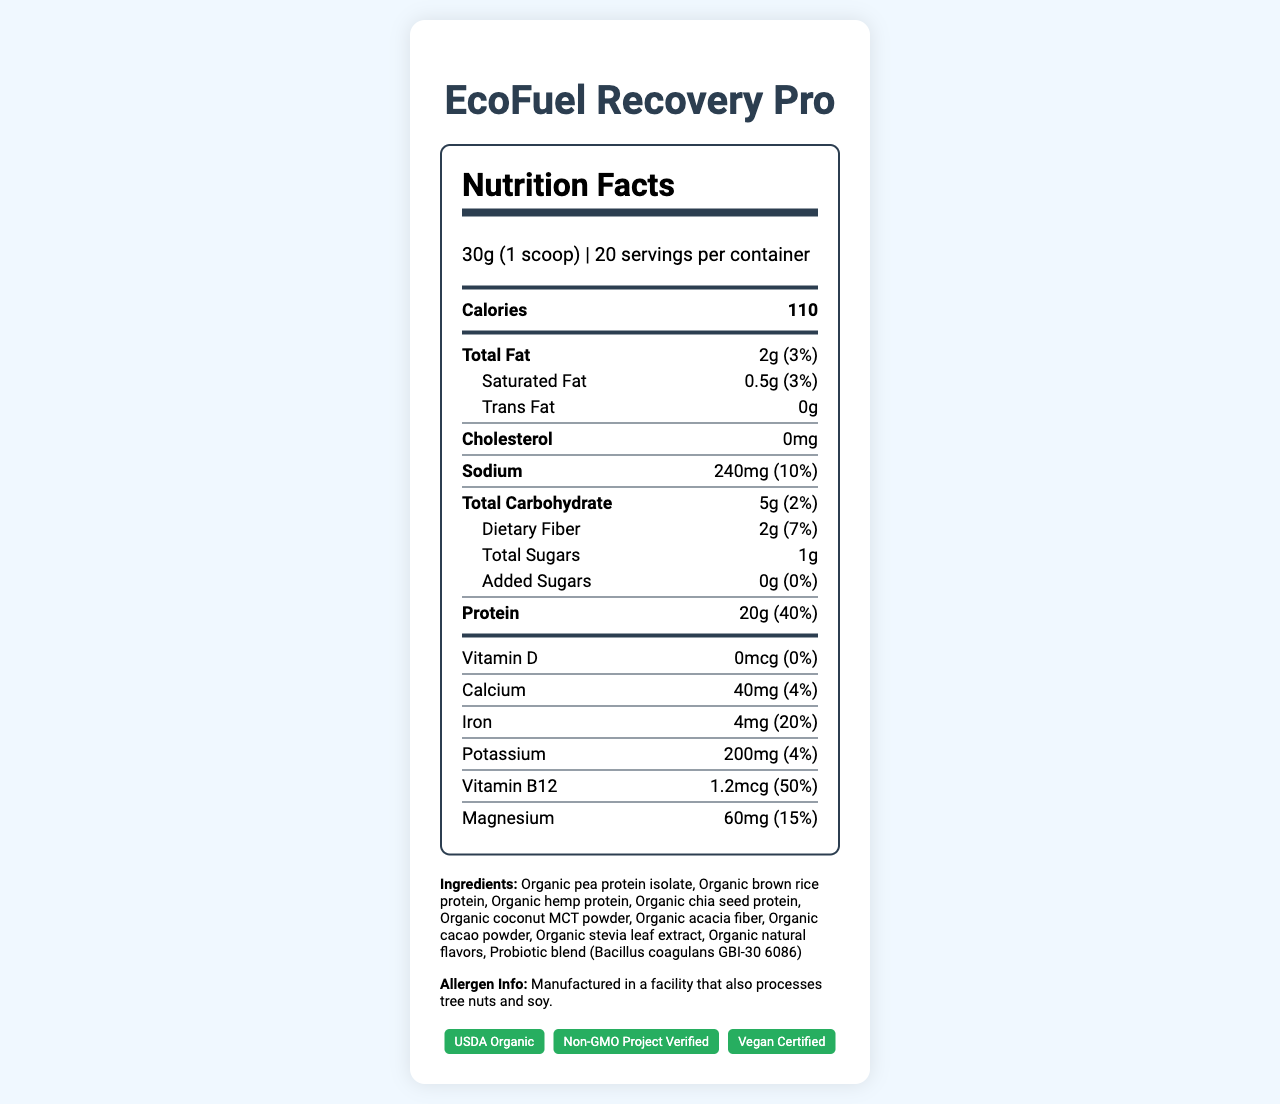who is the target market for EcoFuel Recovery Pro? The "entrepreneur_notes" section specifies the target market for the product.
Answer: Health-conscious professionals and athletes what is the serving size of EcoFuel Recovery Pro? The "serving_size" value indicates that each serving is 30 grams or 1 scoop.
Answer: 30g (1 scoop) how many servings are there per container? The "servings_per_container" field states that there are 20 servings in each container.
Answer: 20 servings per container how many calories are in one serving of EcoFuel Recovery Pro? The "calories" field specifies that one serving has 110 calories.
Answer: 110 calories which certifications does EcoFuel Recovery Pro have? A. USDA Organic B. Non-GMO Project Verified C. Vegan Certified D. All of the above The "certifications" section lists USDA Organic, Non-GMO Project Verified, and Vegan Certified.
Answer: D what is the percentage daily value of protein in one serving? The "protein" field indicates that one serving provides 40% of the daily value of protein.
Answer: 40% how much total fat is in one serving of EcoFuel Recovery Pro? The "total_fat" field shows there are 2 grams of total fat, which is 3% of the daily value.
Answer: 2g (3%) does the product contain any cholesterol? The "cholesterol" field shows 0mg, indicating the product contains no cholesterol.
Answer: No what are the unique selling points of EcoFuel Recovery Pro? The "unique_selling_points" section in the entrepreneur_notes provides these details.
Answer: Organic ingredients for clean energy, diverse protein sources for complete amino acid profile, added probiotics for digestive health, sustainable packaging how much magnesium is in one serving? The "magnesium" field shows that one serving contains 60mg of magnesium, which is 15% of the daily value.
Answer: 60mg (15%) how much added sugar is in one serving? The "added_sugars" field indicates that there is no added sugar in one serving.
Answer: 0g how much iron is in each serving? The "iron" field notes that one serving contains 4mg of iron, or 20% of the daily value.
Answer: 4mg (20% daily value) which ingredient is not in EcoFuel Recovery Pro? A. Organic pea protein isolate B. Whey protein C. Organic chia seed protein D. Organic coconut MCT powder The ingredients list shows no mention of whey protein.
Answer: B what is the primary benefit of subscription model for EcoFuel Recovery Pro described in the document? The "subscription_model" section mentions offering a 15% discount on monthly subscriptions to ensure recurring revenue.
Answer: Ensure recurring revenue with a 15% discount is EcoFuel Recovery Pro manufactured in a facility that processes tree nuts? The allergen_info indicates that the product is manufactured in a facility that also processes tree nuts and soy.
Answer: Yes what benefits do probiotics add to EcoFuel Recovery Pro? The entrepreneur_notes section states that added probiotics support digestive health.
Answer: Digestive health what is the total carbohydrate content per serving? The "total_carbohydrate" field indicates that one serving contains 5g of carbohydrates, which is 2% of the daily value.
Answer: 5g (2% daily value) describe the main idea of the document. This summary highlights the key aspects of EcoFuel Recovery Pro, including its nutritional values, unique selling points, and target market.
Answer: EcoFuel Recovery Pro is an organic, plant-based protein powder formulated to support muscle recovery and sustained energy, targeting health-conscious professionals and athletes. It features a diverse protein profile, added probiotics, and sustainability certifications. It has 110 calories per serving and provides significant protein while having low fat and no added sugars. The product also contains 20 servings per container, is allergy-aware, and offers potential cross-sell and subscription opportunities. can you calculate the total grams of protein in the entire container? With 20 servings per container and 20g of protein per serving, the total protein is 20 servings * 20g = 400g.
Answer: 400g what is the profit margin for EcoFuel Recovery Pro? The entrepreneur_notes section specifies that the profit margin is 40% per container.
Answer: 40% per container what is the manufacturing facility’s address? The document does not provide the address of the manufacturing facility.
Answer: Not enough information 